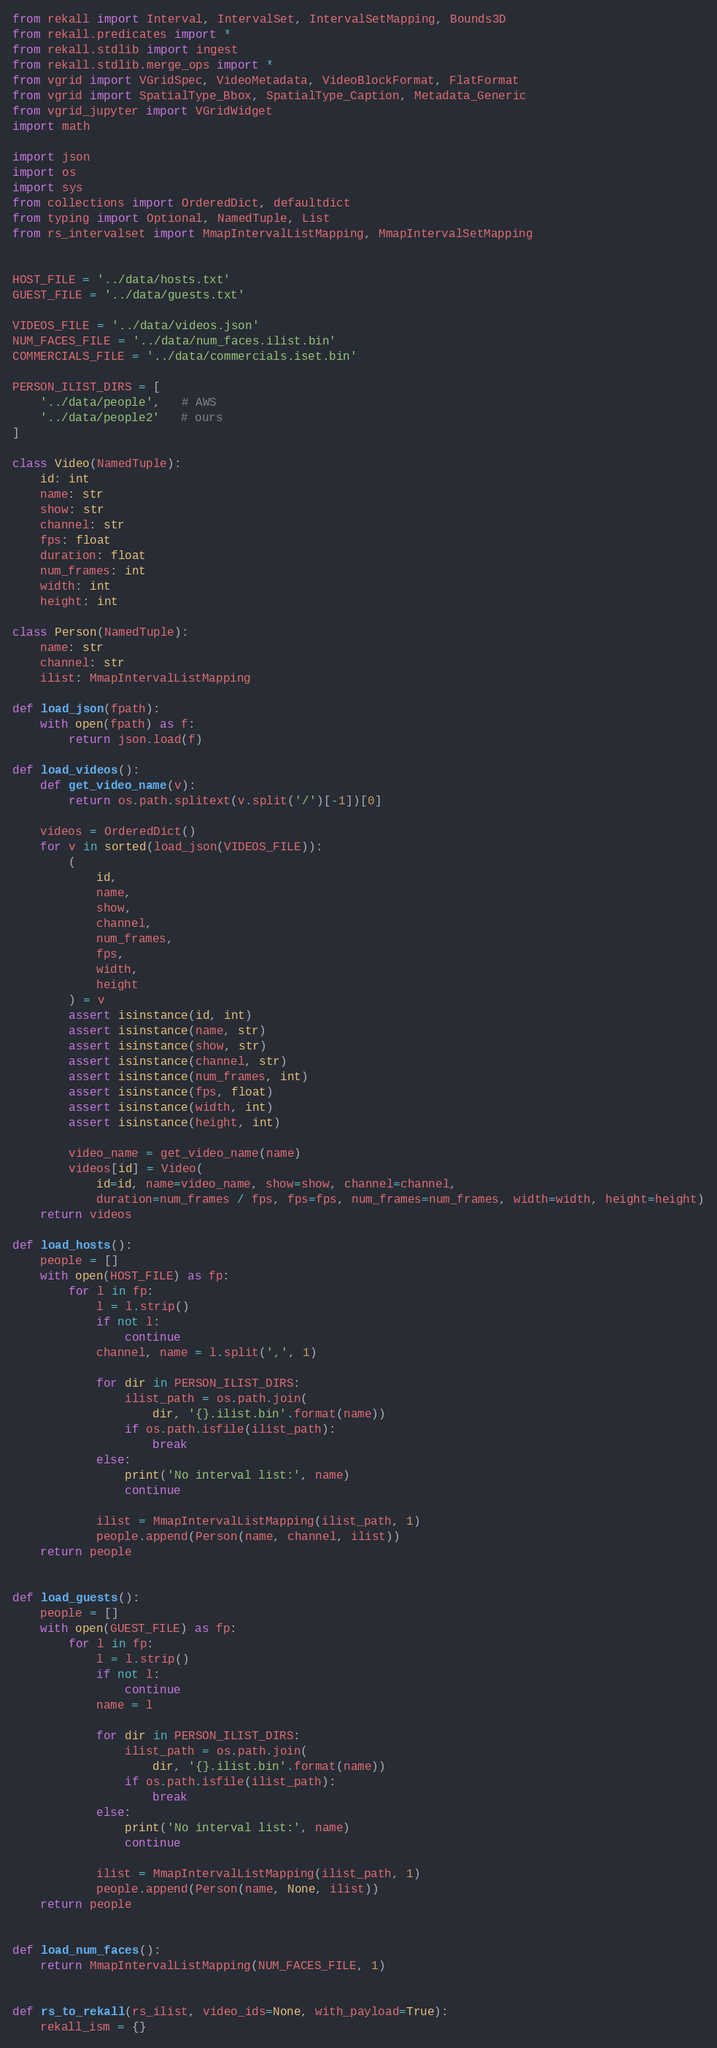<code> <loc_0><loc_0><loc_500><loc_500><_Python_>from rekall import Interval, IntervalSet, IntervalSetMapping, Bounds3D
from rekall.predicates import *
from rekall.stdlib import ingest
from rekall.stdlib.merge_ops import *
from vgrid import VGridSpec, VideoMetadata, VideoBlockFormat, FlatFormat
from vgrid import SpatialType_Bbox, SpatialType_Caption, Metadata_Generic
from vgrid_jupyter import VGridWidget
import math

import json
import os
import sys
from collections import OrderedDict, defaultdict
from typing import Optional, NamedTuple, List
from rs_intervalset import MmapIntervalListMapping, MmapIntervalSetMapping


HOST_FILE = '../data/hosts.txt'
GUEST_FILE = '../data/guests.txt'

VIDEOS_FILE = '../data/videos.json'
NUM_FACES_FILE = '../data/num_faces.ilist.bin'
COMMERCIALS_FILE = '../data/commercials.iset.bin'

PERSON_ILIST_DIRS = [
    '../data/people',   # AWS
    '../data/people2'   # ours
]

class Video(NamedTuple):
    id: int
    name: str
    show: str
    channel: str
    fps: float
    duration: float
    num_frames: int
    width: int
    height: int

class Person(NamedTuple):
    name: str
    channel: str
    ilist: MmapIntervalListMapping
        
def load_json(fpath):
    with open(fpath) as f:
        return json.load(f)
        
def load_videos():
    def get_video_name(v):
        return os.path.splitext(v.split('/')[-1])[0]

    videos = OrderedDict()
    for v in sorted(load_json(VIDEOS_FILE)):
        (
            id,
            name,
            show,
            channel,
            num_frames,
            fps,
            width,
            height
        ) = v
        assert isinstance(id, int)
        assert isinstance(name, str)
        assert isinstance(show, str)
        assert isinstance(channel, str)
        assert isinstance(num_frames, int)
        assert isinstance(fps, float)
        assert isinstance(width, int)
        assert isinstance(height, int)

        video_name = get_video_name(name)
        videos[id] = Video(
            id=id, name=video_name, show=show, channel=channel,
            duration=num_frames / fps, fps=fps, num_frames=num_frames, width=width, height=height)
    return videos
        
def load_hosts():
    people = []
    with open(HOST_FILE) as fp:
        for l in fp:
            l = l.strip()
            if not l:
                continue
            channel, name = l.split(',', 1)

            for dir in PERSON_ILIST_DIRS:
                ilist_path = os.path.join(
                    dir, '{}.ilist.bin'.format(name))
                if os.path.isfile(ilist_path):
                    break
            else:
                print('No interval list:', name)
                continue

            ilist = MmapIntervalListMapping(ilist_path, 1)
            people.append(Person(name, channel, ilist))
    return people


def load_guests():
    people = []
    with open(GUEST_FILE) as fp:
        for l in fp:
            l = l.strip()
            if not l:
                continue
            name = l

            for dir in PERSON_ILIST_DIRS:
                ilist_path = os.path.join(
                    dir, '{}.ilist.bin'.format(name))
                if os.path.isfile(ilist_path):
                    break
            else:
                print('No interval list:', name)
                continue

            ilist = MmapIntervalListMapping(ilist_path, 1)
            people.append(Person(name, None, ilist))
    return people


def load_num_faces():
    return MmapIntervalListMapping(NUM_FACES_FILE, 1)


def rs_to_rekall(rs_ilist, video_ids=None, with_payload=True):
    rekall_ism = {}</code> 